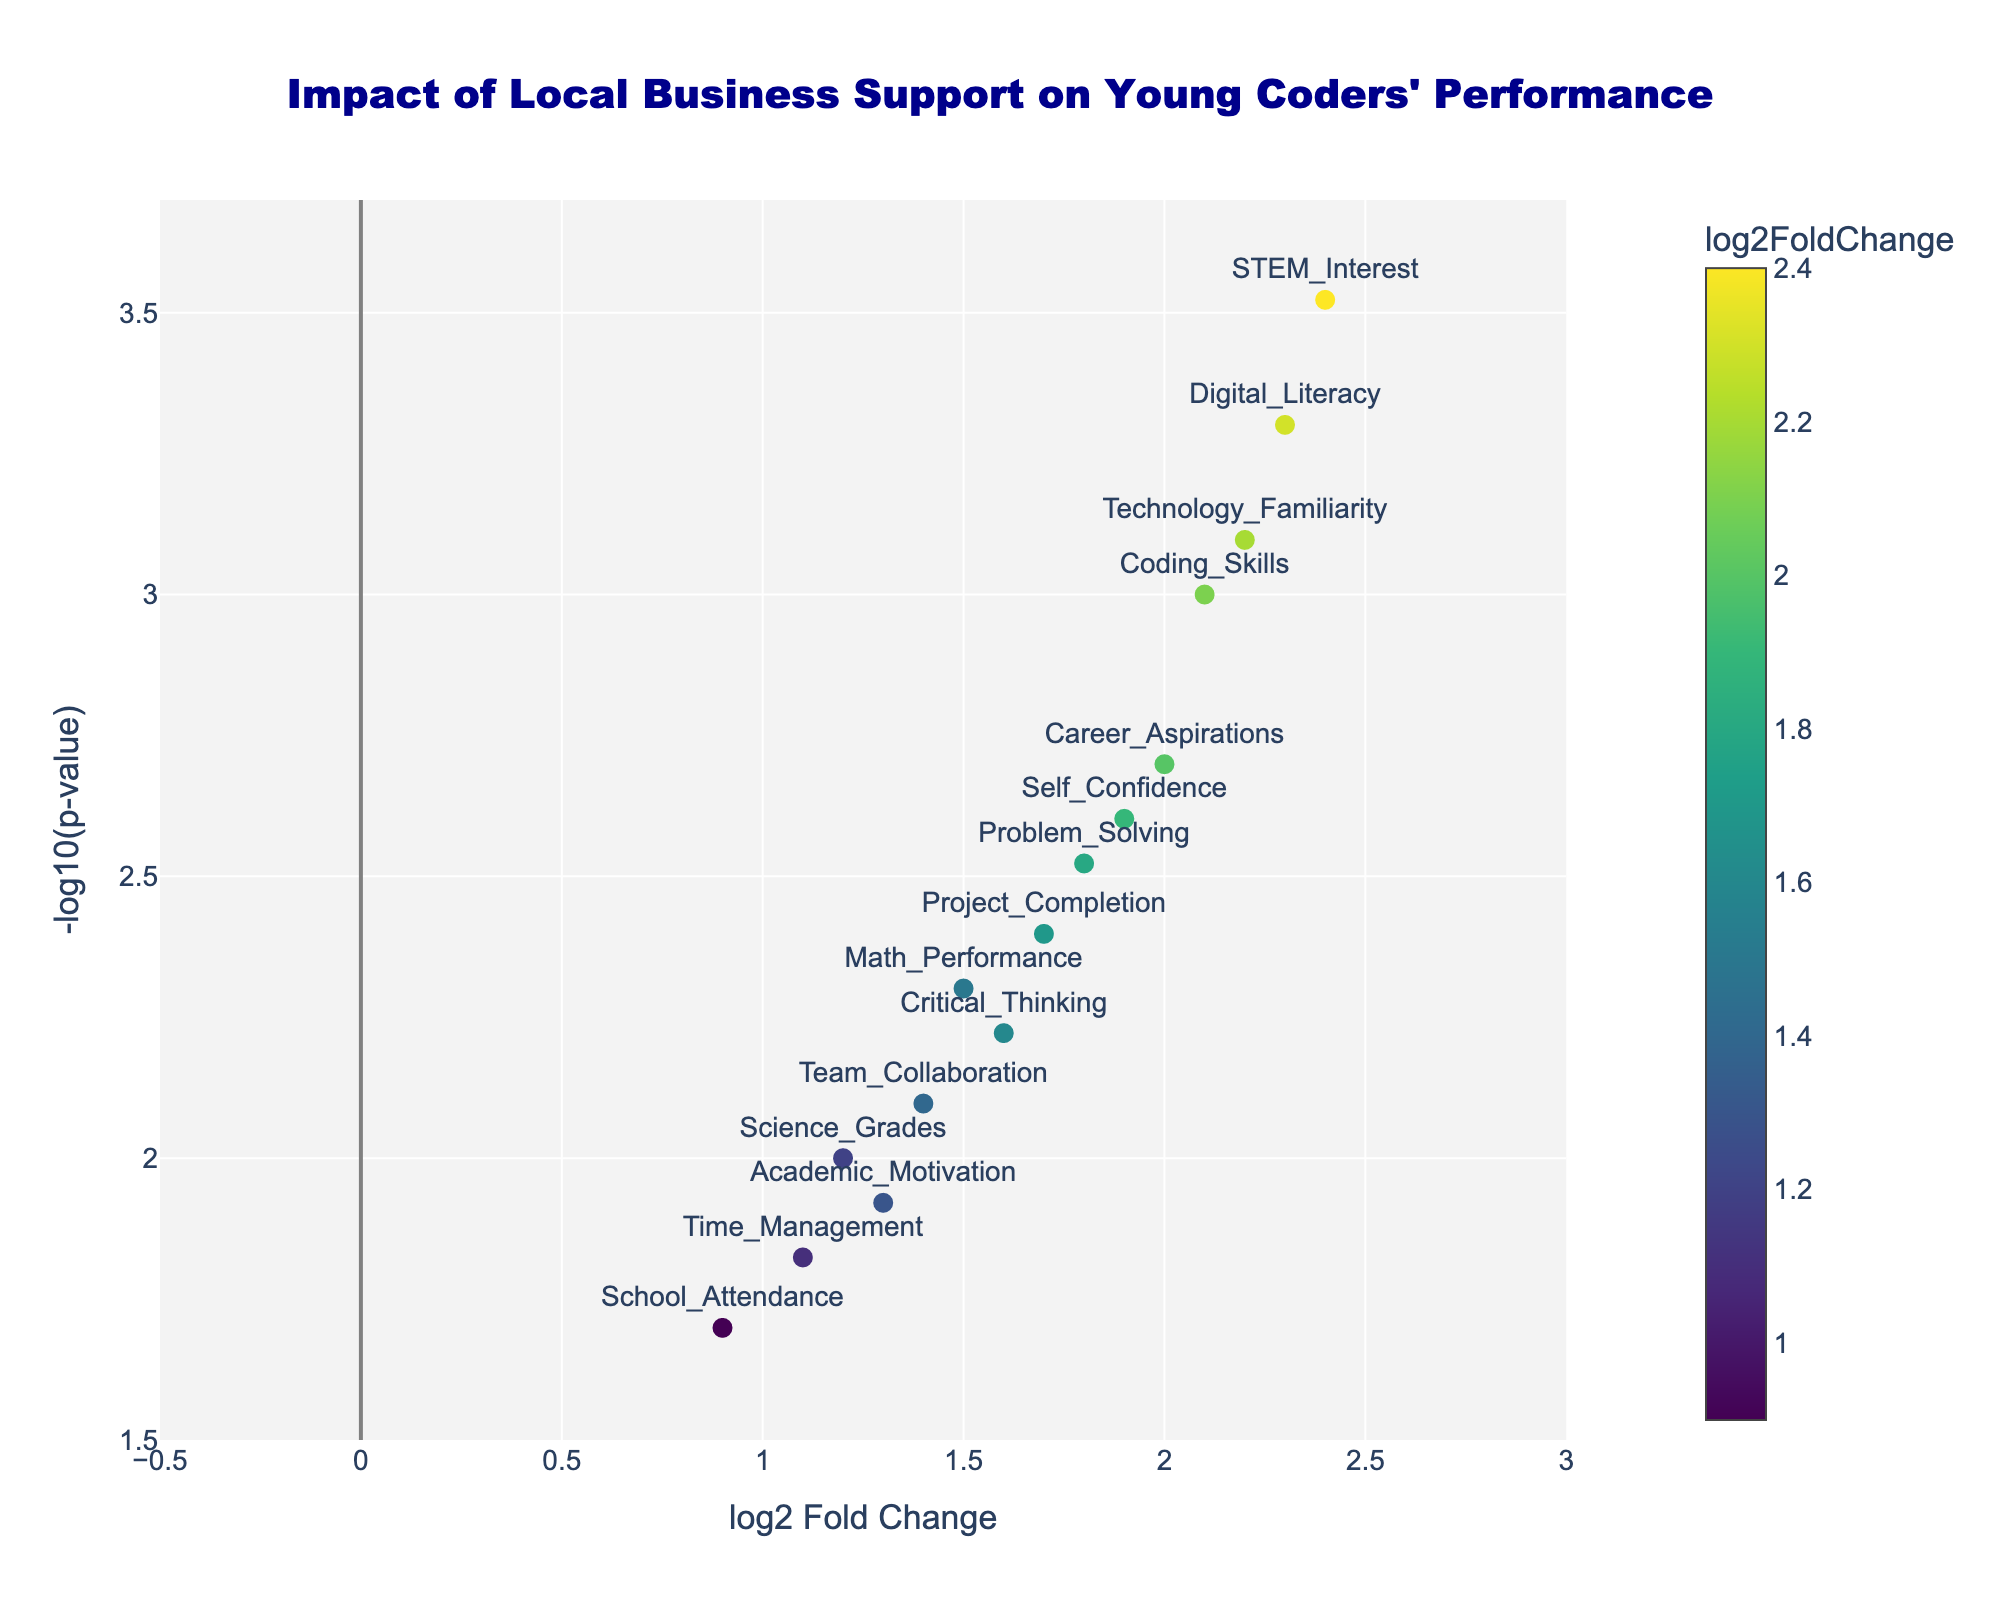What's the title of the figure? The figure title is usually shown at the top and here it states, "Impact of Local Business Support on Young Coders' Performance". You can see the title clearly marked at the top in dark blue.
Answer: Impact of Local Business Support on Young Coders' Performance What does the x-axis represent? The x-axis represents the "log2 Fold Change" which measures the ratio of change in young coders' performance metrics due to local business support, illustrated in logarithmic scale to base 2.
Answer: log2 Fold Change What does the y-axis represent? The y-axis represents "-log10 of p-value" which indicates the statistical significance of the changes observed. A higher value means more statistically significant results.
Answer: -log10(p-value) Which performance metric has the highest statistical significance? To find the highest statistical significance, look for the highest value on the y-axis. The point corresponding to "STEM_Interest" is the highest on the y-axis with a -log10(p-value) of 3.52, indicating it has the highest statistical significance.
Answer: STEM_Interest Which metric shows the greatest increase in performance due to local business support? The "log2 Fold Change" value indicates the increase in performance. The metric "STEM_Interest" has the highest log2FoldChange value of 2.4, which is the greatest increase in performance due to local business support.
Answer: STEM_Interest What metric has a log2FoldChange closest to 1.5? To find the closest match to 1.5 on the x-axis, the metric "Math_Performance" has a log2FoldChange value of 1.5.
Answer: Math_Performance How many metrics have a log2FoldChange greater than 2? By visually counting the points on the plot where the log2FoldChange is greater than 2, metrics like "Coding_Skills", "Digital_Literacy", "Technology_Familiarity", and "STEM_Interest" meet this criterion.
Answer: 4 Is there any metric with a -log10(p-value) lower than 2? To determine this, look for points below the 2.0 mark on the y-axis. "School_Attendance" (0.9, 1.70), "Time_Management" (1.1, 1.82), and "Academic_Motivation" (1.3, 1.92) have -log10(p-value) values lower than 2.
Answer: Yes Which metric has the second highest log2FoldChange? "Digital_Literacy" has a log2FoldChange of 2.3, which is the second highest after "STEM_Interest" at 2.4.
Answer: Digital_Literacy Which metrics show significant improvement with p-values below 0.005? Identified by looking for points with y-axis values above -log10(p-value) of 2.3 (as -log10(0.005) = 2.3), the performance metrics are: "Coding_Skills" (2.1, 3.00), "Problem_Solving" (1.8, 2.52), "Digital_Literacy" (2.3, 3.30), "Project_Completion" (1.7, 2.40), "Critical_Thinking" (1.6, 2.52), "Career_Aspirations" (2.0, 2.70), "Self_Confidence" (1.9, 2.70), "Technology_Familiarity" (2.2, 3.10), "STEM_Interest" (2.4, 3.52).
Answer: 9 